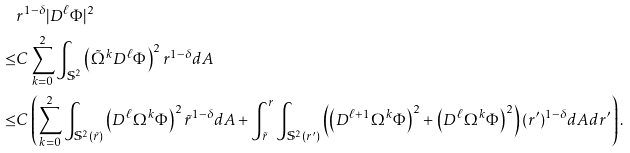Convert formula to latex. <formula><loc_0><loc_0><loc_500><loc_500>& r ^ { 1 - \delta } | D ^ { \ell } \Phi | ^ { 2 } \\ \leq & C \sum _ { k = 0 } ^ { 2 } \int _ { \mathbb { S } ^ { 2 } } \left ( \tilde { \Omega } ^ { k } D ^ { \ell } \Phi \right ) ^ { 2 } r ^ { 1 - \delta } d A \\ \leq & C \left ( \sum _ { k = 0 } ^ { 2 } \int _ { \mathbb { S } ^ { 2 } ( \tilde { r } ) } \left ( D ^ { \ell } \Omega ^ { k } \Phi \right ) ^ { 2 } \tilde { r } ^ { 1 - \delta } d A + \int _ { \tilde { r } } ^ { r } \int _ { \mathbb { S } ^ { 2 } ( r ^ { \prime } ) } \left ( \left ( D ^ { \ell + 1 } \Omega ^ { k } \Phi \right ) ^ { 2 } + \left ( D ^ { \ell } \Omega ^ { k } \Phi \right ) ^ { 2 } \right ) ( r ^ { \prime } ) ^ { 1 - \delta } d A d r ^ { \prime } \right ) . \\</formula> 